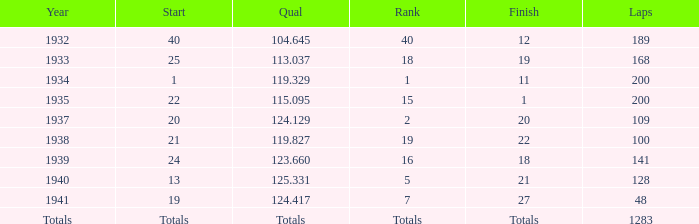660? 18.0. 